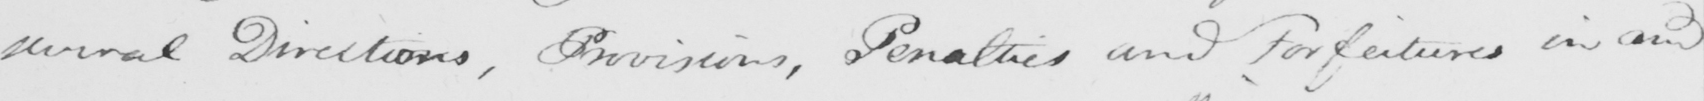Please transcribe the handwritten text in this image. several Directions , Provisions , Penalties and Forfeitures in and 